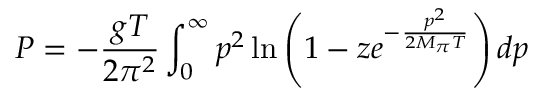Convert formula to latex. <formula><loc_0><loc_0><loc_500><loc_500>P = - \frac { g T } { 2 \pi ^ { 2 } } \int _ { 0 } ^ { \infty } p ^ { 2 } \ln \left ( 1 - z e ^ { - \frac { p ^ { 2 } } { 2 M _ { \pi } T } } \right ) d p</formula> 